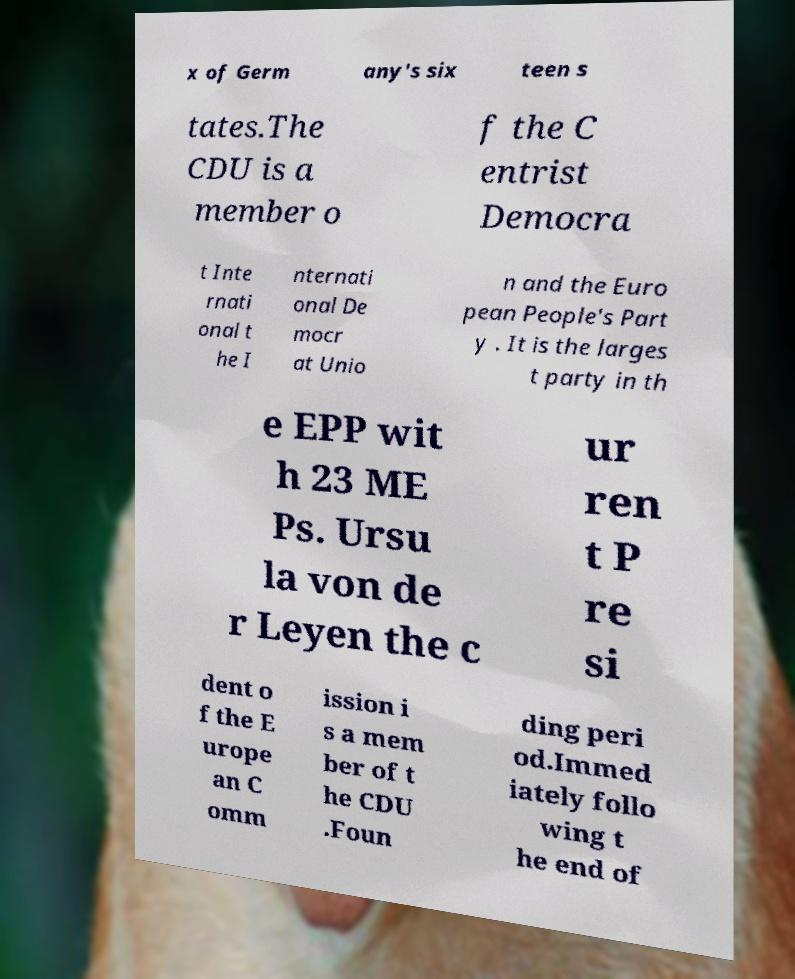Could you extract and type out the text from this image? x of Germ any's six teen s tates.The CDU is a member o f the C entrist Democra t Inte rnati onal t he I nternati onal De mocr at Unio n and the Euro pean People's Part y . It is the larges t party in th e EPP wit h 23 ME Ps. Ursu la von de r Leyen the c ur ren t P re si dent o f the E urope an C omm ission i s a mem ber of t he CDU .Foun ding peri od.Immed iately follo wing t he end of 